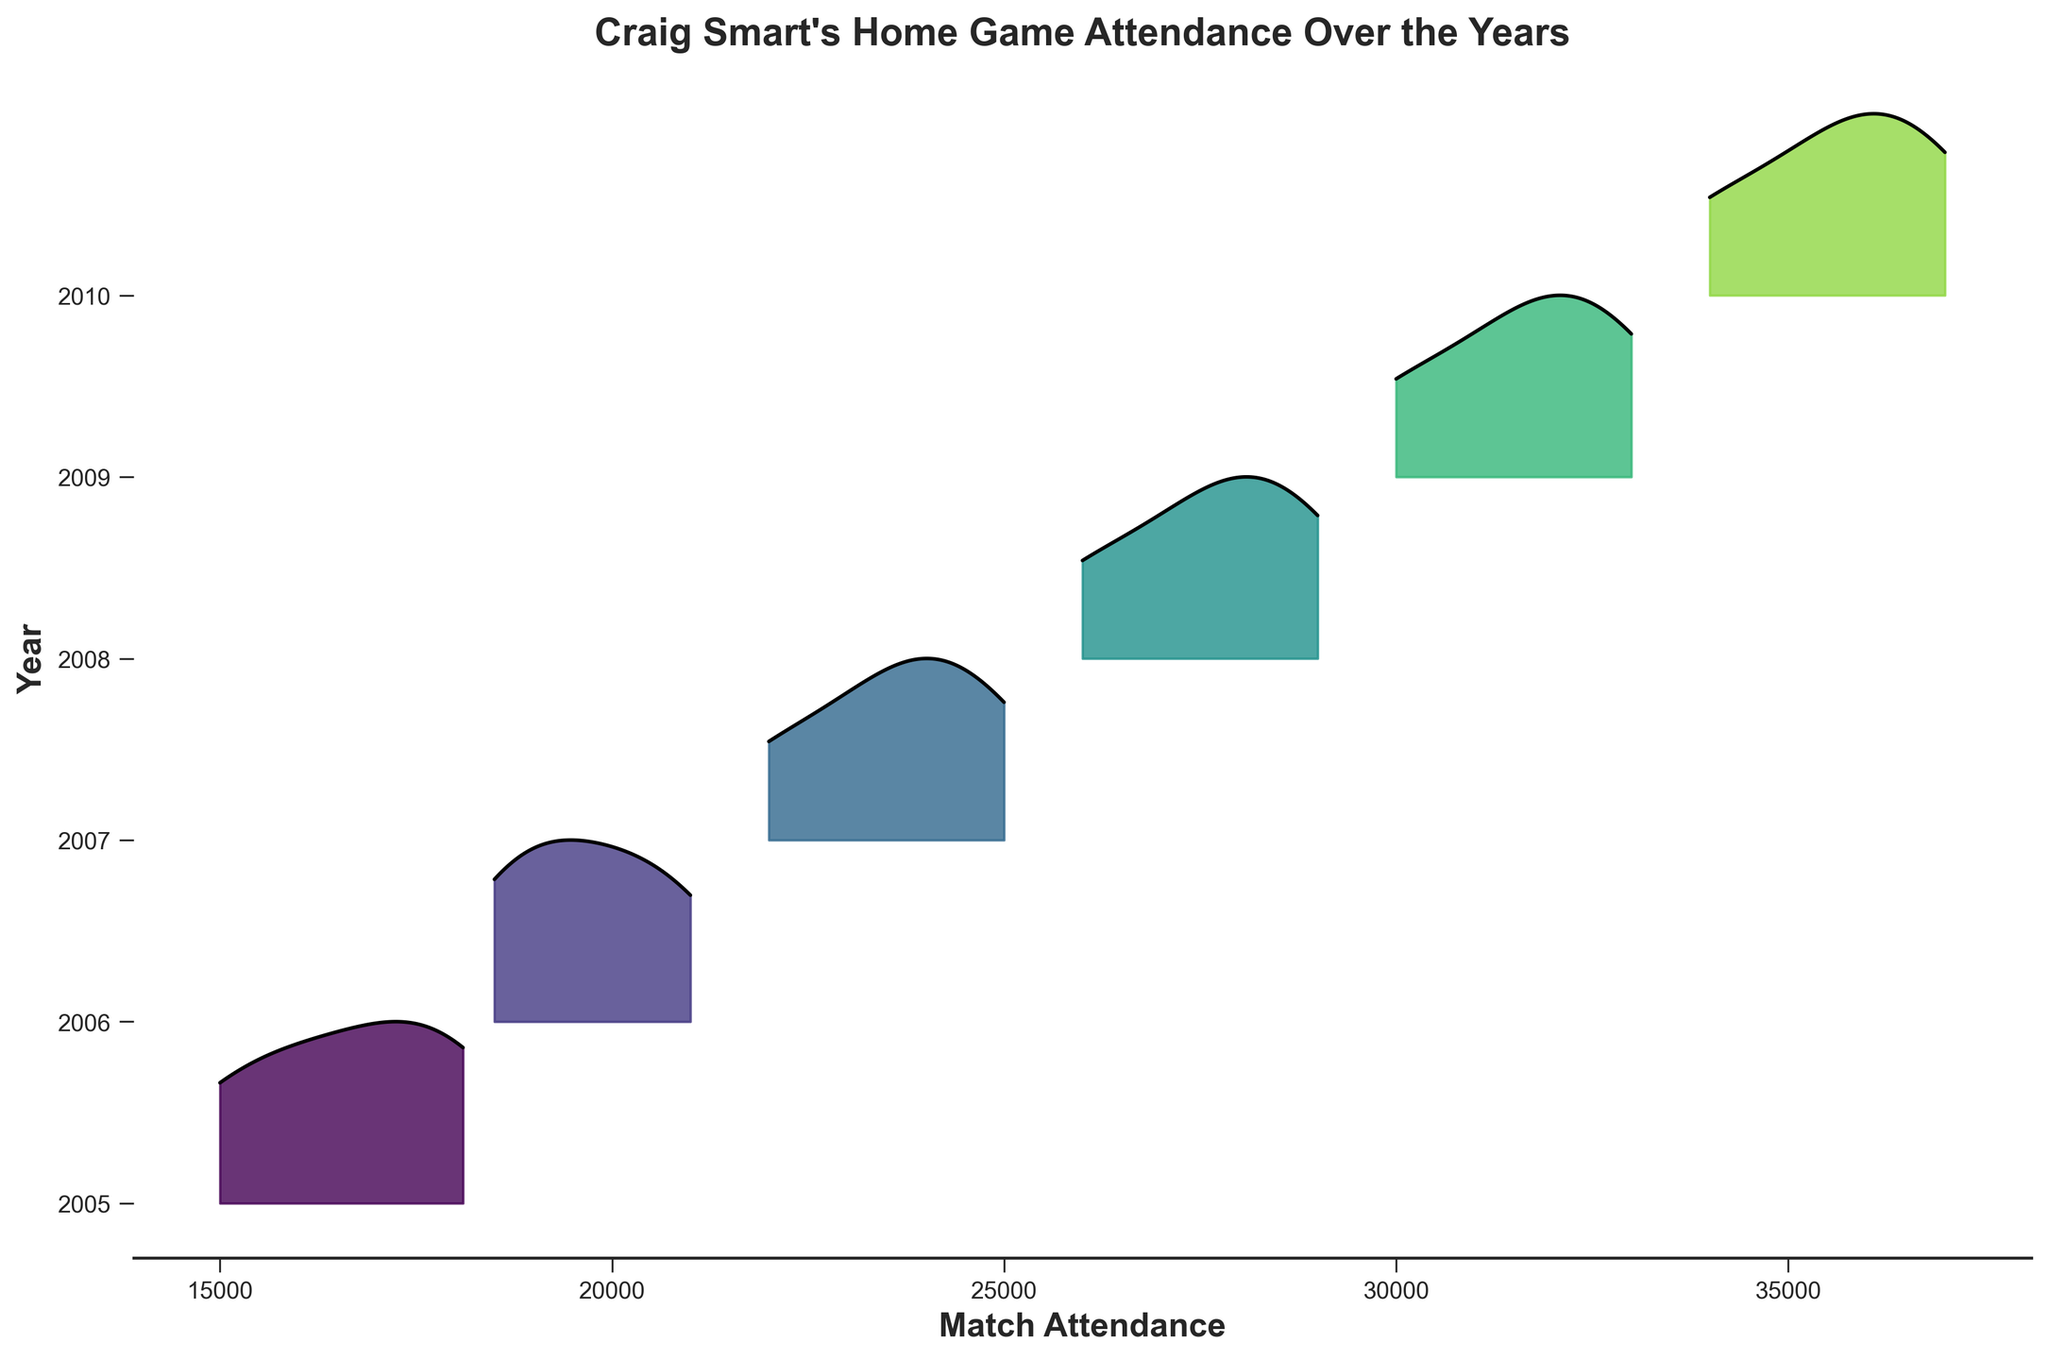what is the title of the plot? The title is located at the top of the figure and provides a summary of what the plot represents. In this case, it is "Craig Smart's Home Game Attendance Over the Years".
Answer: Craig Smart's Home Game Attendance Over the Years what years are displayed on the y-axis? The y-axis represents the years for which match attendance data is available. You can see the years listed along the y-axis ticks starting from 2005 to 2010.
Answer: 2005 to 2010 how does the attendance trend change over the years? The trend can be observed by looking at the density shapes for each year. Each successive year shows higher attendance overall, with the peak values and larger densities increasing year by year. This indicates a positive trend in match attendance over the years.
Answer: Increasing which year had the highest peak attendance density? Identify the year with the tallest peak in its density curve, reflecting the highest concentration of attendance figures. Here, 2010 shows the highest peak on the plot.
Answer: 2010 how does the attendance distribution in 2005 compare to that in 2010? Compare the shapes and positions of the density plots for 2005 and 2010. 2010's density plot is shifted to the right and is higher overall than that of 2005, indicating higher attendance values and more consistency in attendance.
Answer: Higher and more consistent in 2010 what is the attendance range for the year 2008? The range is determined by the minimum and maximum values of the attendance density plot for 2008. The density plot runs from around 26000 to 29000 attendees.
Answer: 26000 to 29000 attendees which year experienced the largest increase in match attendance figures compared to the previous year? To determine the largest increase, observe the gaps between density plots year over year. The year 2008 saw a significant increase compared to 2007, showing a larger upward shift on the x-axis.
Answer: 2008 is the overall distribution of attendance more skewed to the left or right? Skewness can be identified by looking at the density plots' shapes. Most densities have their peaks more on the left side of their respective plots, suggesting a left skew.
Answer: Left skewed which year had the most diverse range of attendance figures? Diversity in range can be observed by looking at the spread of the density plots for each year. 2009 has the broadest spread, indicating a diverse range of attendance figures.
Answer: 2009 what is the primary insight you can derive from this plot? The primary insight is that Craig Smart's home game attendance figures have generally increased year by year, with 2010 having the highest and most consistent attendance. This indicates growing popularity and sustained interest in his home games over the years.
Answer: Increasing popularity and sustained interest 